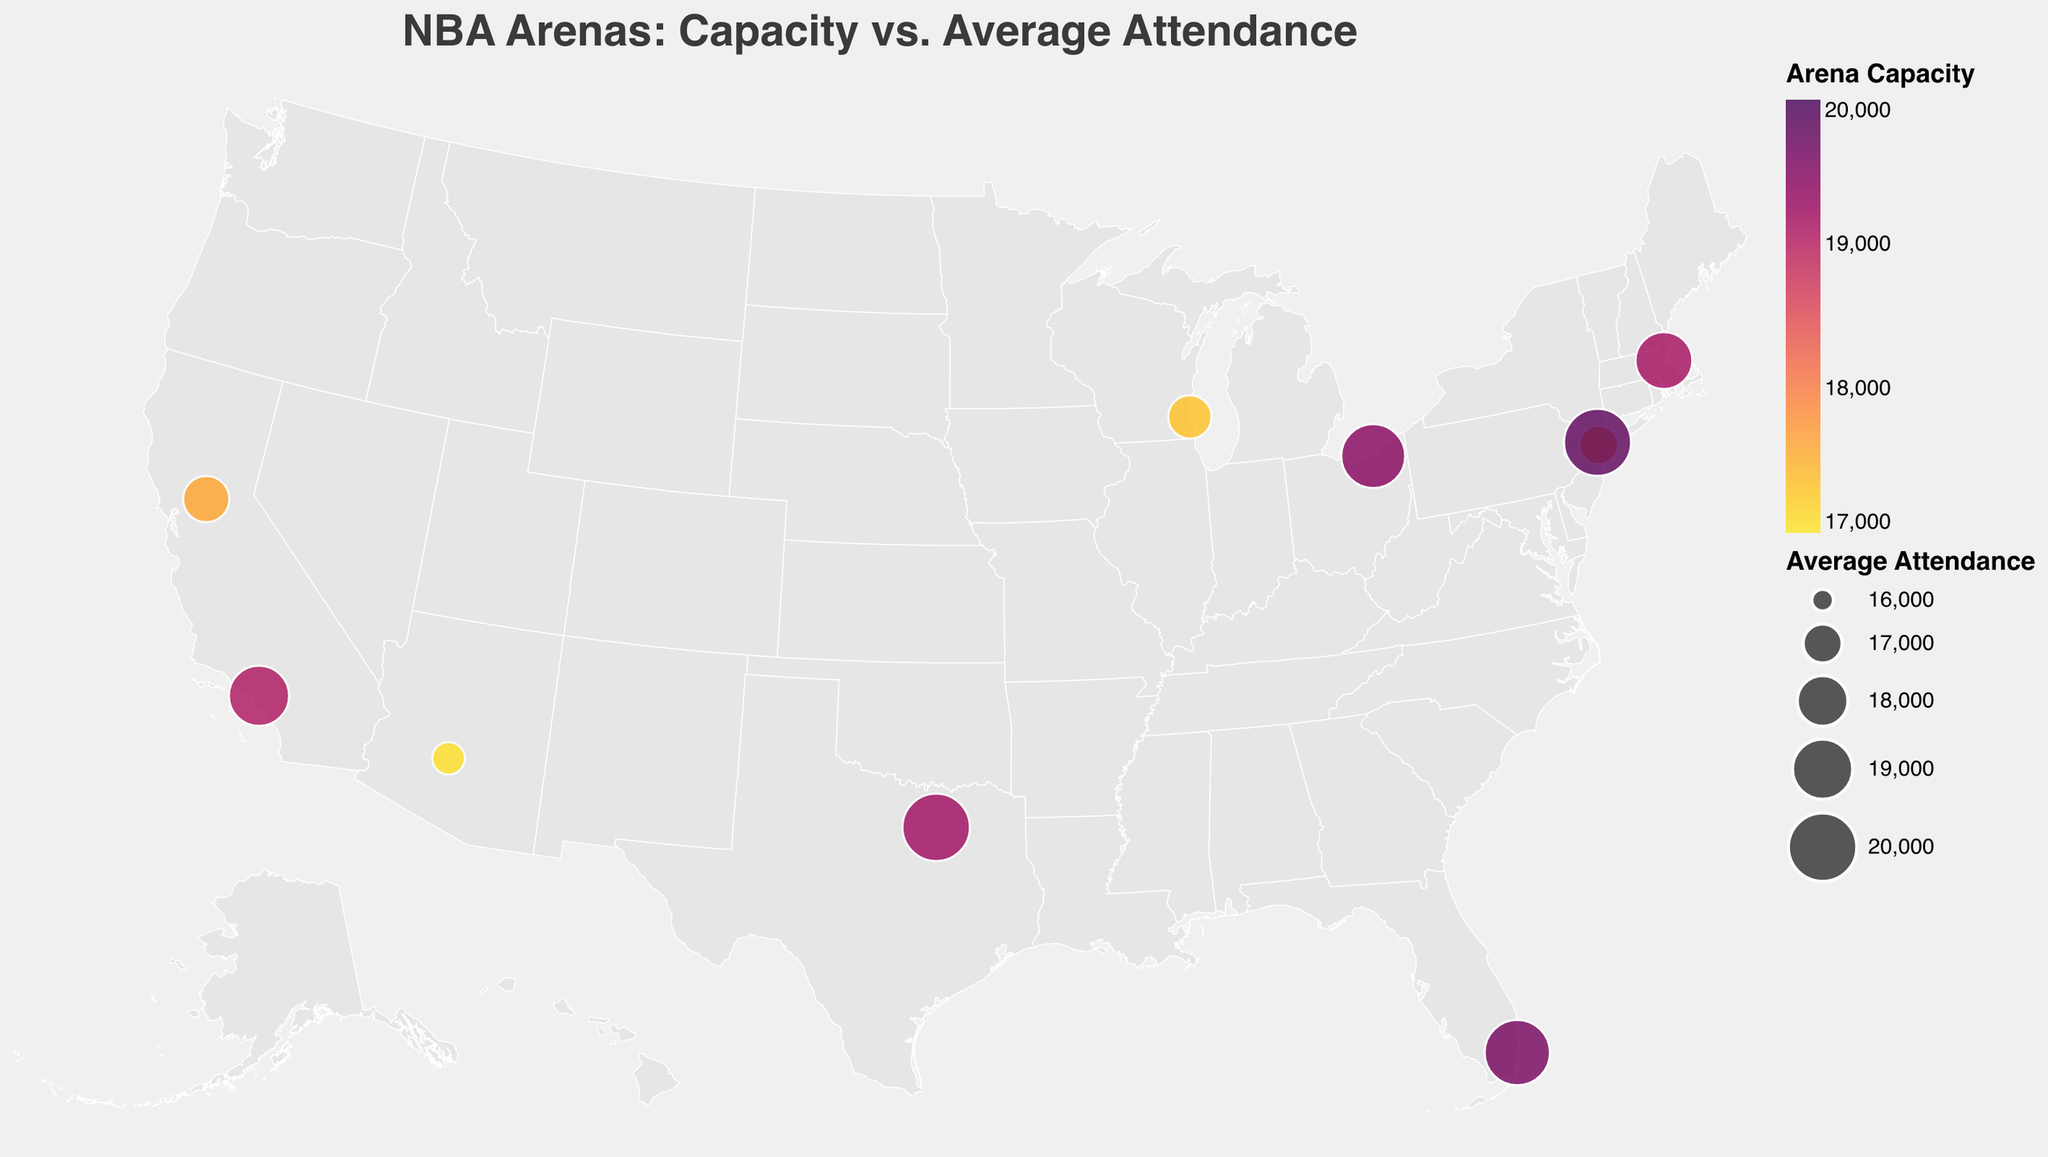what is the title of the plot? The title is usually displayed prominently at the top of the figure. It helps to quickly understand the main topic of the visualization.
Answer: NBA Arenas: Capacity vs. Average Attendance which arena has the highest average attendance? To find this out, we need to look at the arena with the largest size of the circle.
Answer: American Airlines Center and Madison Square Garden what is the attendance difference between Barclays Center and FTX Arena? To get this, subtract the average attendance of Barclays Center from that of FTX Arena. Barclays Center: 16964, FTX Arena: 19600.
Answer: 2636 which state has the most arenas represented in the plot? Check the state column for each arena and count the occurrences. New York has Barclays Center and Madison Square Garden.
Answer: New York which arena has the smallest capacity, and what is its average attendance? To know this, look at the smallest value in the capacity field and refer to its corresponding average attendance. Fiserv Forum has the smallest capacity at 17341.
Answer: 17341 where is Madison Square Garden located? Check the city and state columns for Madison Square Garden.
Answer: New York, NY which arena has the lowest average attendance and what is its capacity? The arena with the smallest size circle represents the lowest average attendance. This is Footprint Center with 16562.
Answer: 17071 how does Kyrie Irving's points per game (PPG) correlate with the capacity of the arenas? Compare the capacities with Kyrie's PPG at each venue. The highest PPG, 28.5, is at Madison Square Garden.
Answer: higher capacity generally has higher kyrie_ppg compare the average attendance between TD Garden and American Airlines Center Find the average attendance for both arenas and compare them. TD Garden: 18624, American Airlines Center: 19862
Answer: American Airlines Center has higher average attendance what are the latitude and longitude of Crypto.com Arena? Look at the latitude and longitude values for Crypto.com Arena.
Answer: Latitude: 34.043, Longitude: -118.2673 